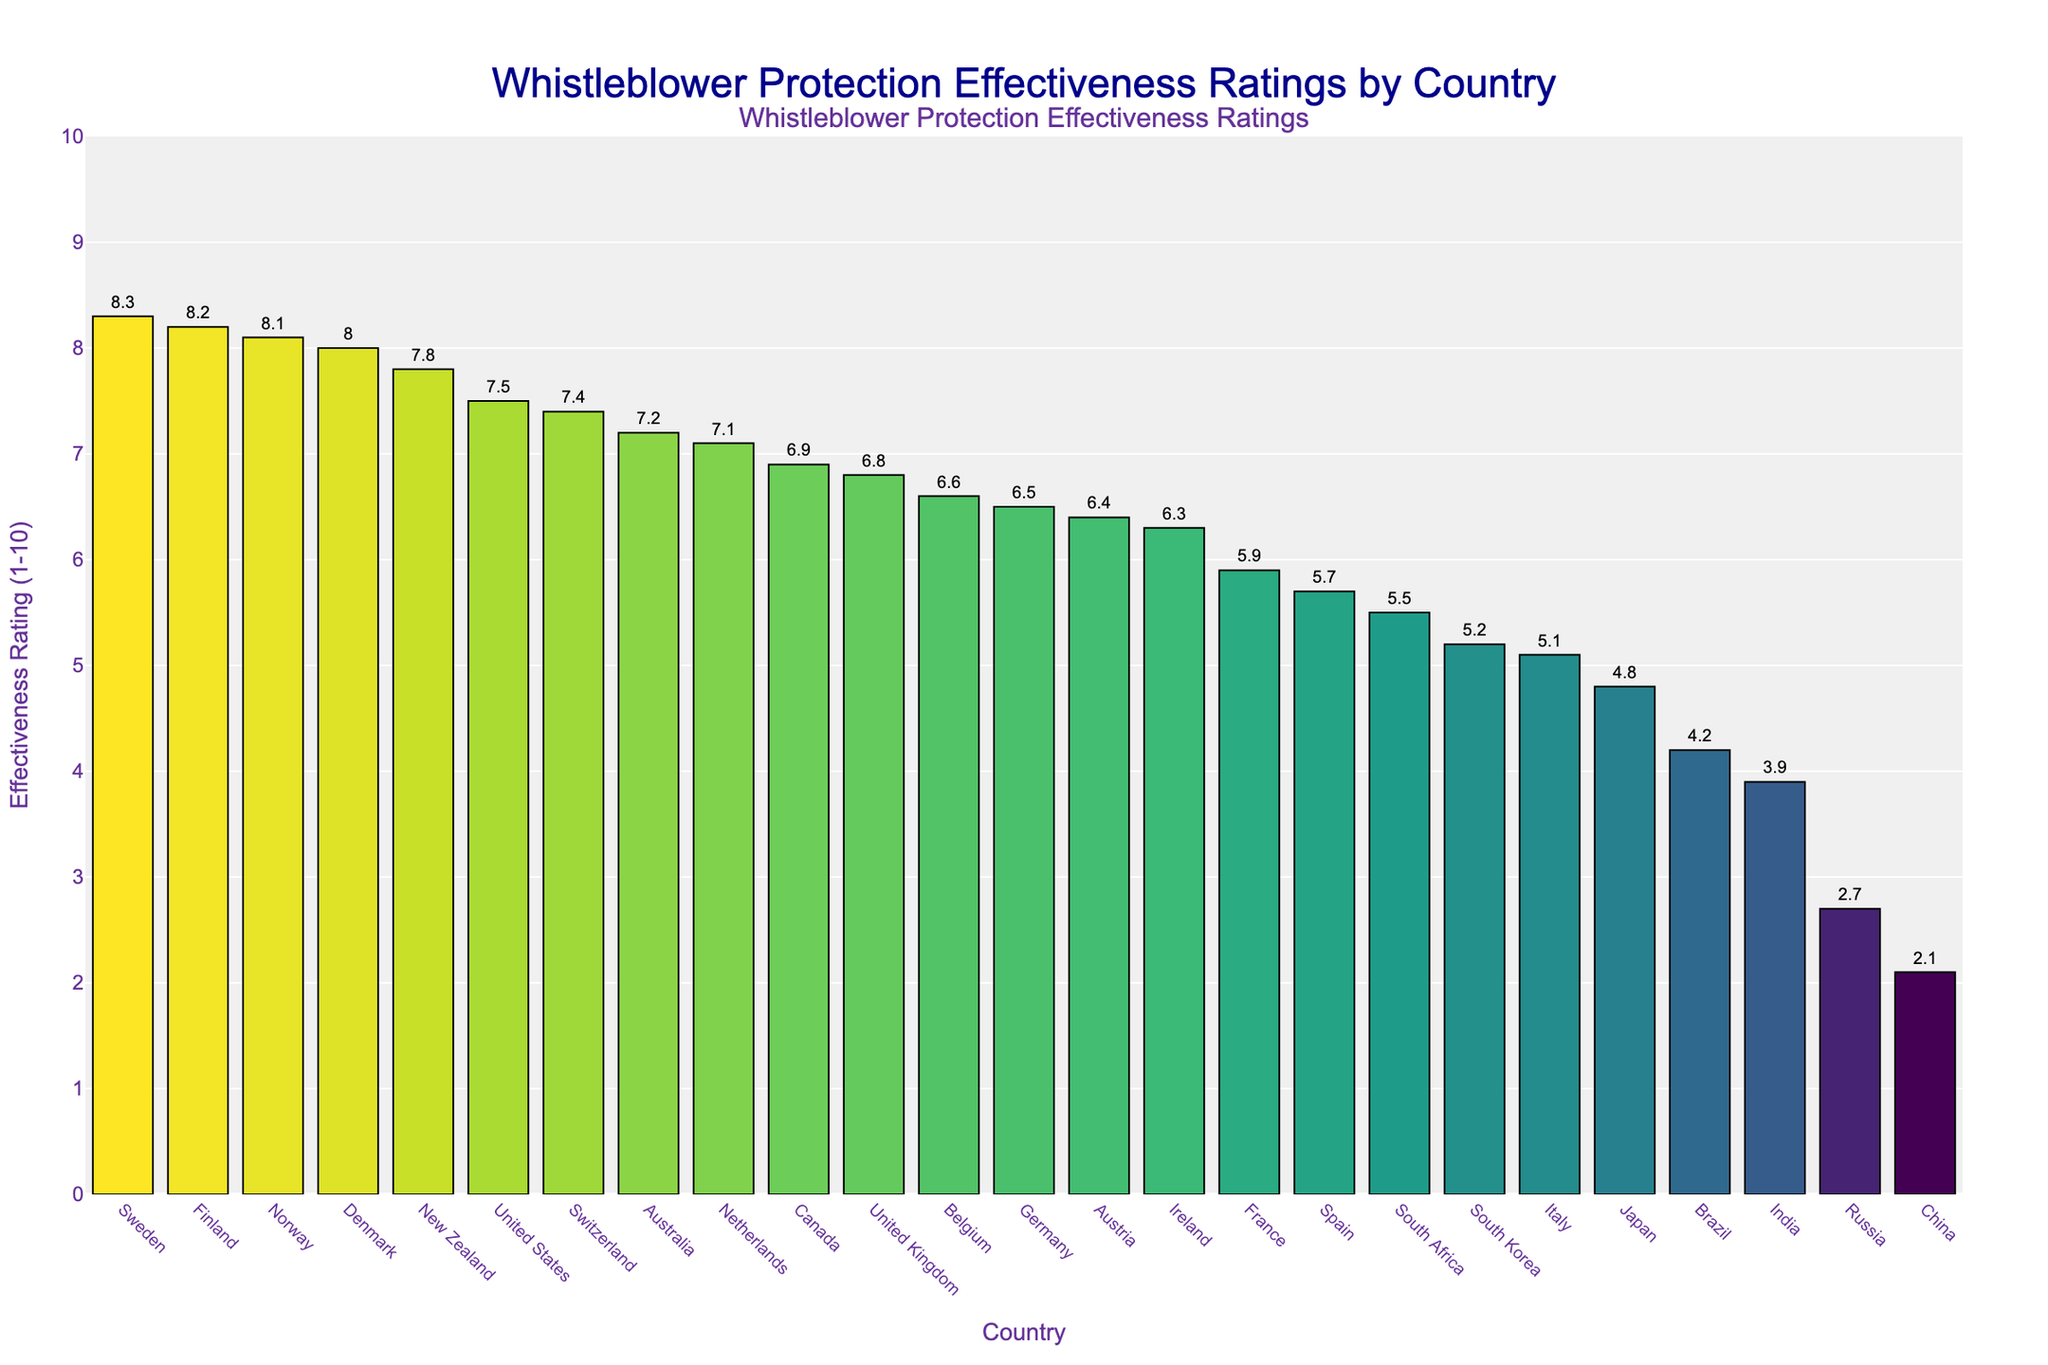What's the highest Whistleblower Protection Effectiveness Rating and which country has it? By examining the bar heights, Sweden has the highest rating, which is clearly higher than the other bars. The rating for Sweden is 8.3.
Answer: 8.3, Sweden Which countries have a Whistleblower Protection Effectiveness Rating of 7.4 or higher? Visually, the bars corresponding to ratings of 7.4 and above are among the tallest. By identifying these bars, the countries are United States (7.5), Australia (7.2), Netherlands (7.1), Sweden (8.3), Norway (8.1), Denmark (8.0), and Switzerland (7.4).
Answer: United States, Australia, Netherlands, Sweden, Norway, Denmark, Switzerland How many countries have a rating above 6 but below 8? By checking the bars whose ratings fall between 6 and 8, we can count the countries: United States (7.5), United Kingdom (6.8), Australia (7.2), Canada (6.9), Netherlands (7.1), New Zealand (7.8), Belgium (6.6), Austria (6.4), and Switzerland (7.4). There are 9 countries within this range.
Answer: 9 Which country has the lowest Whistleblower Protection Effectiveness Rating and what is the rating? The shortest bar represents the country with the lowest rating. China has the lowest rating, which is 2.1.
Answer: 2.1, China What is the average Whistleblower Protection Effectiveness Rating of the top 5 countries? First, identify the top 5 countries (Sweden, Norway, Finland, Denmark, New Zealand). Their ratings are 8.3, 8.2, 8.1, 8.0, and 7.8. Add them up: 8.3 + 8.2 + 8.1 + 8.0 + 7.8 = 40.4. Now, divide by 5: 40.4 / 5 = 8.08.
Answer: 8.08 Which countries have ratings less than 5? By examining the shorter bars, the countries with ratings less than 5 are Japan (4.8), South Korea (5.2), South Africa (5.5), Brazil (4.2), India (3.9), Russia (2.7), China (2.1), and Italy (5.1). On closer inspection, Italy and South Korea do not qualify, so the final list is Japan, Brazil, India, Russia, and China.
Answer: Japan, Brazil, India, Russia, China Which countries have the same rating? By comparing the bars visually, we can see that no two bars align perfectly on the y-axis, indicating no two countries have the same rating in the dataset.
Answer: None What is the range of the Whistleblower Protection Effectiveness Ratings? The range is calculated by subtracting the lowest rating from the highest rating. The highest rating is 8.3 (Sweden) and the lowest rating is 2.1 (China). So, the range is 8.3 - 2.1 = 6.2.
Answer: 6.2 